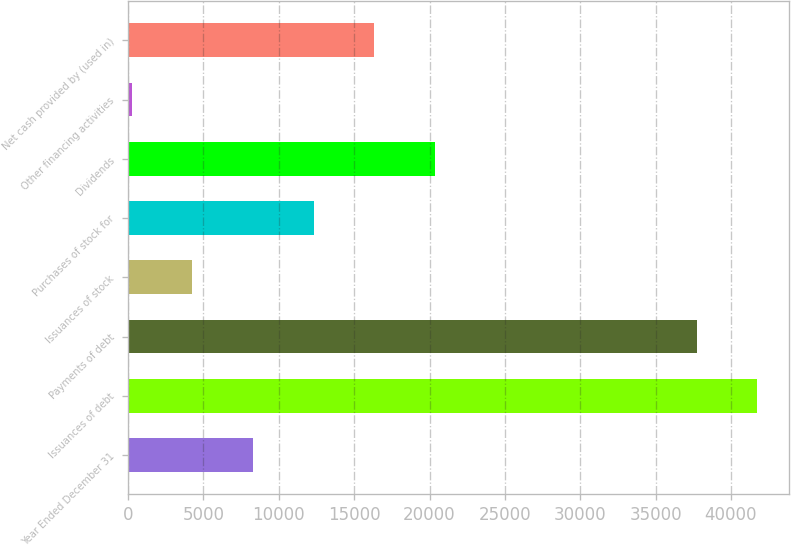<chart> <loc_0><loc_0><loc_500><loc_500><bar_chart><fcel>Year Ended December 31<fcel>Issuances of debt<fcel>Payments of debt<fcel>Issuances of stock<fcel>Purchases of stock for<fcel>Dividends<fcel>Other financing activities<fcel>Net cash provided by (used in)<nl><fcel>8287.6<fcel>41756.3<fcel>37738<fcel>4269.3<fcel>12305.9<fcel>20342.5<fcel>251<fcel>16324.2<nl></chart> 